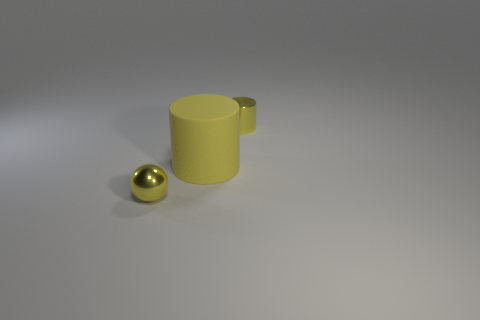How many other things are there of the same size as the yellow shiny ball?
Your response must be concise. 1. What is the size of the object that is both on the right side of the small metallic ball and on the left side of the tiny yellow shiny cylinder?
Your answer should be very brief. Large. There is a big object; is its color the same as the tiny object behind the small yellow metal sphere?
Ensure brevity in your answer.  Yes. Is there a yellow shiny object of the same shape as the large yellow rubber thing?
Your answer should be compact. Yes. What number of objects are either big objects or small yellow metal things right of the tiny metal sphere?
Offer a terse response. 2. How many other things are there of the same material as the sphere?
Provide a succinct answer. 1. How many things are either tiny yellow metallic cylinders or large blue rubber blocks?
Give a very brief answer. 1. Are there more tiny shiny objects that are in front of the metal sphere than tiny metal cylinders to the right of the small metallic cylinder?
Your answer should be compact. No. There is a cylinder that is in front of the tiny yellow cylinder; does it have the same color as the thing that is right of the large matte cylinder?
Keep it short and to the point. Yes. What is the size of the metallic thing in front of the yellow metallic object behind the small object that is on the left side of the big yellow object?
Make the answer very short. Small. 